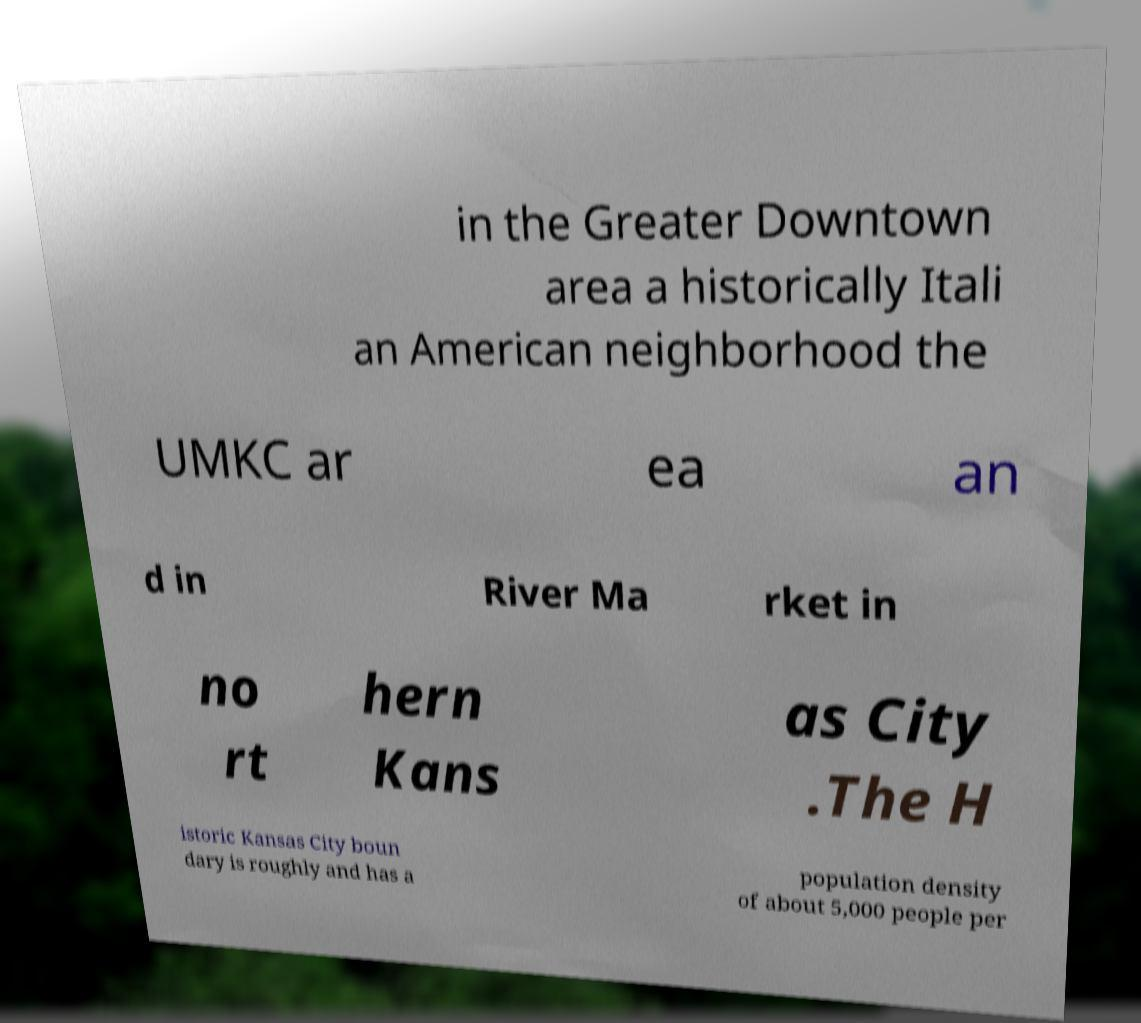For documentation purposes, I need the text within this image transcribed. Could you provide that? in the Greater Downtown area a historically Itali an American neighborhood the UMKC ar ea an d in River Ma rket in no rt hern Kans as City .The H istoric Kansas City boun dary is roughly and has a population density of about 5,000 people per 